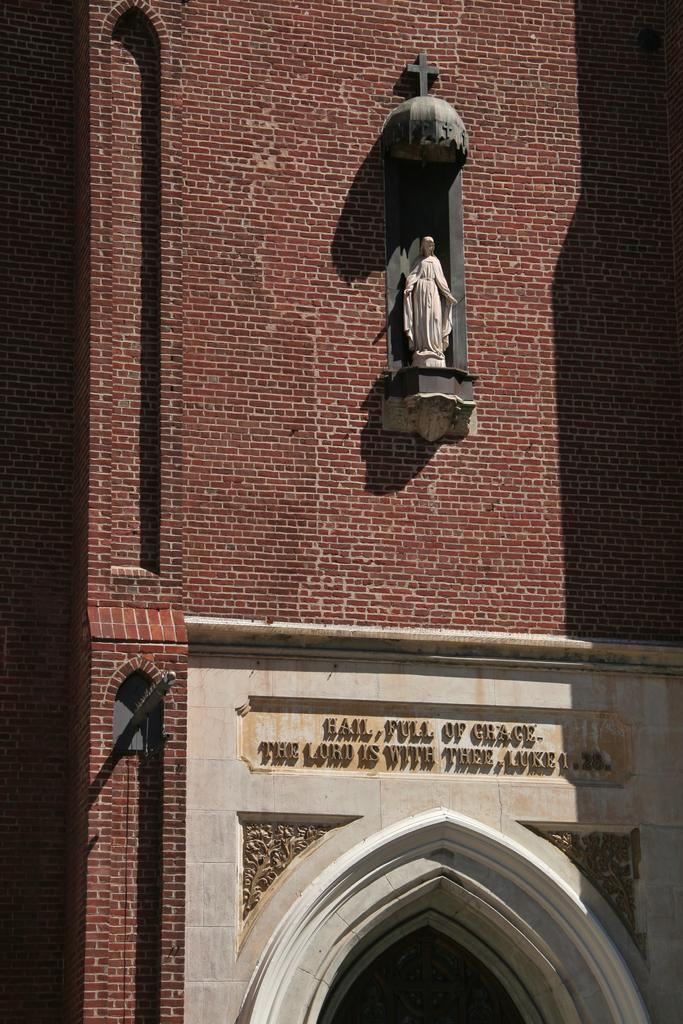What type of structure is depicted in the image? The image is of a building. Are there any additional features on the building? Yes, there is a statue on the building. What can be seen on the wall of the building? There is text on the wall of the building. What type of magic is being performed by the statue in the image? There is no magic being performed by the statue in the image; it is a stationary object on the building. 